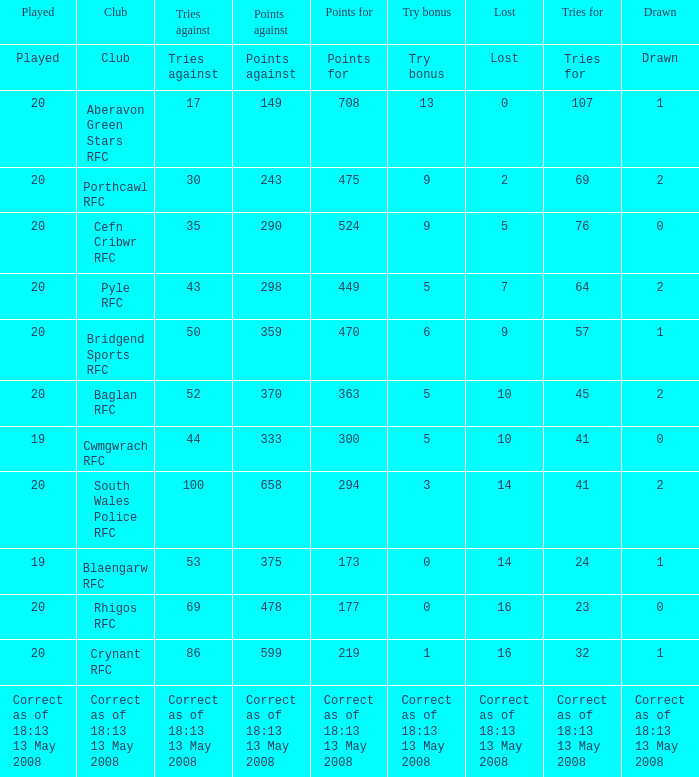What club has a played number of 19, and the lost of 14? Blaengarw RFC. 